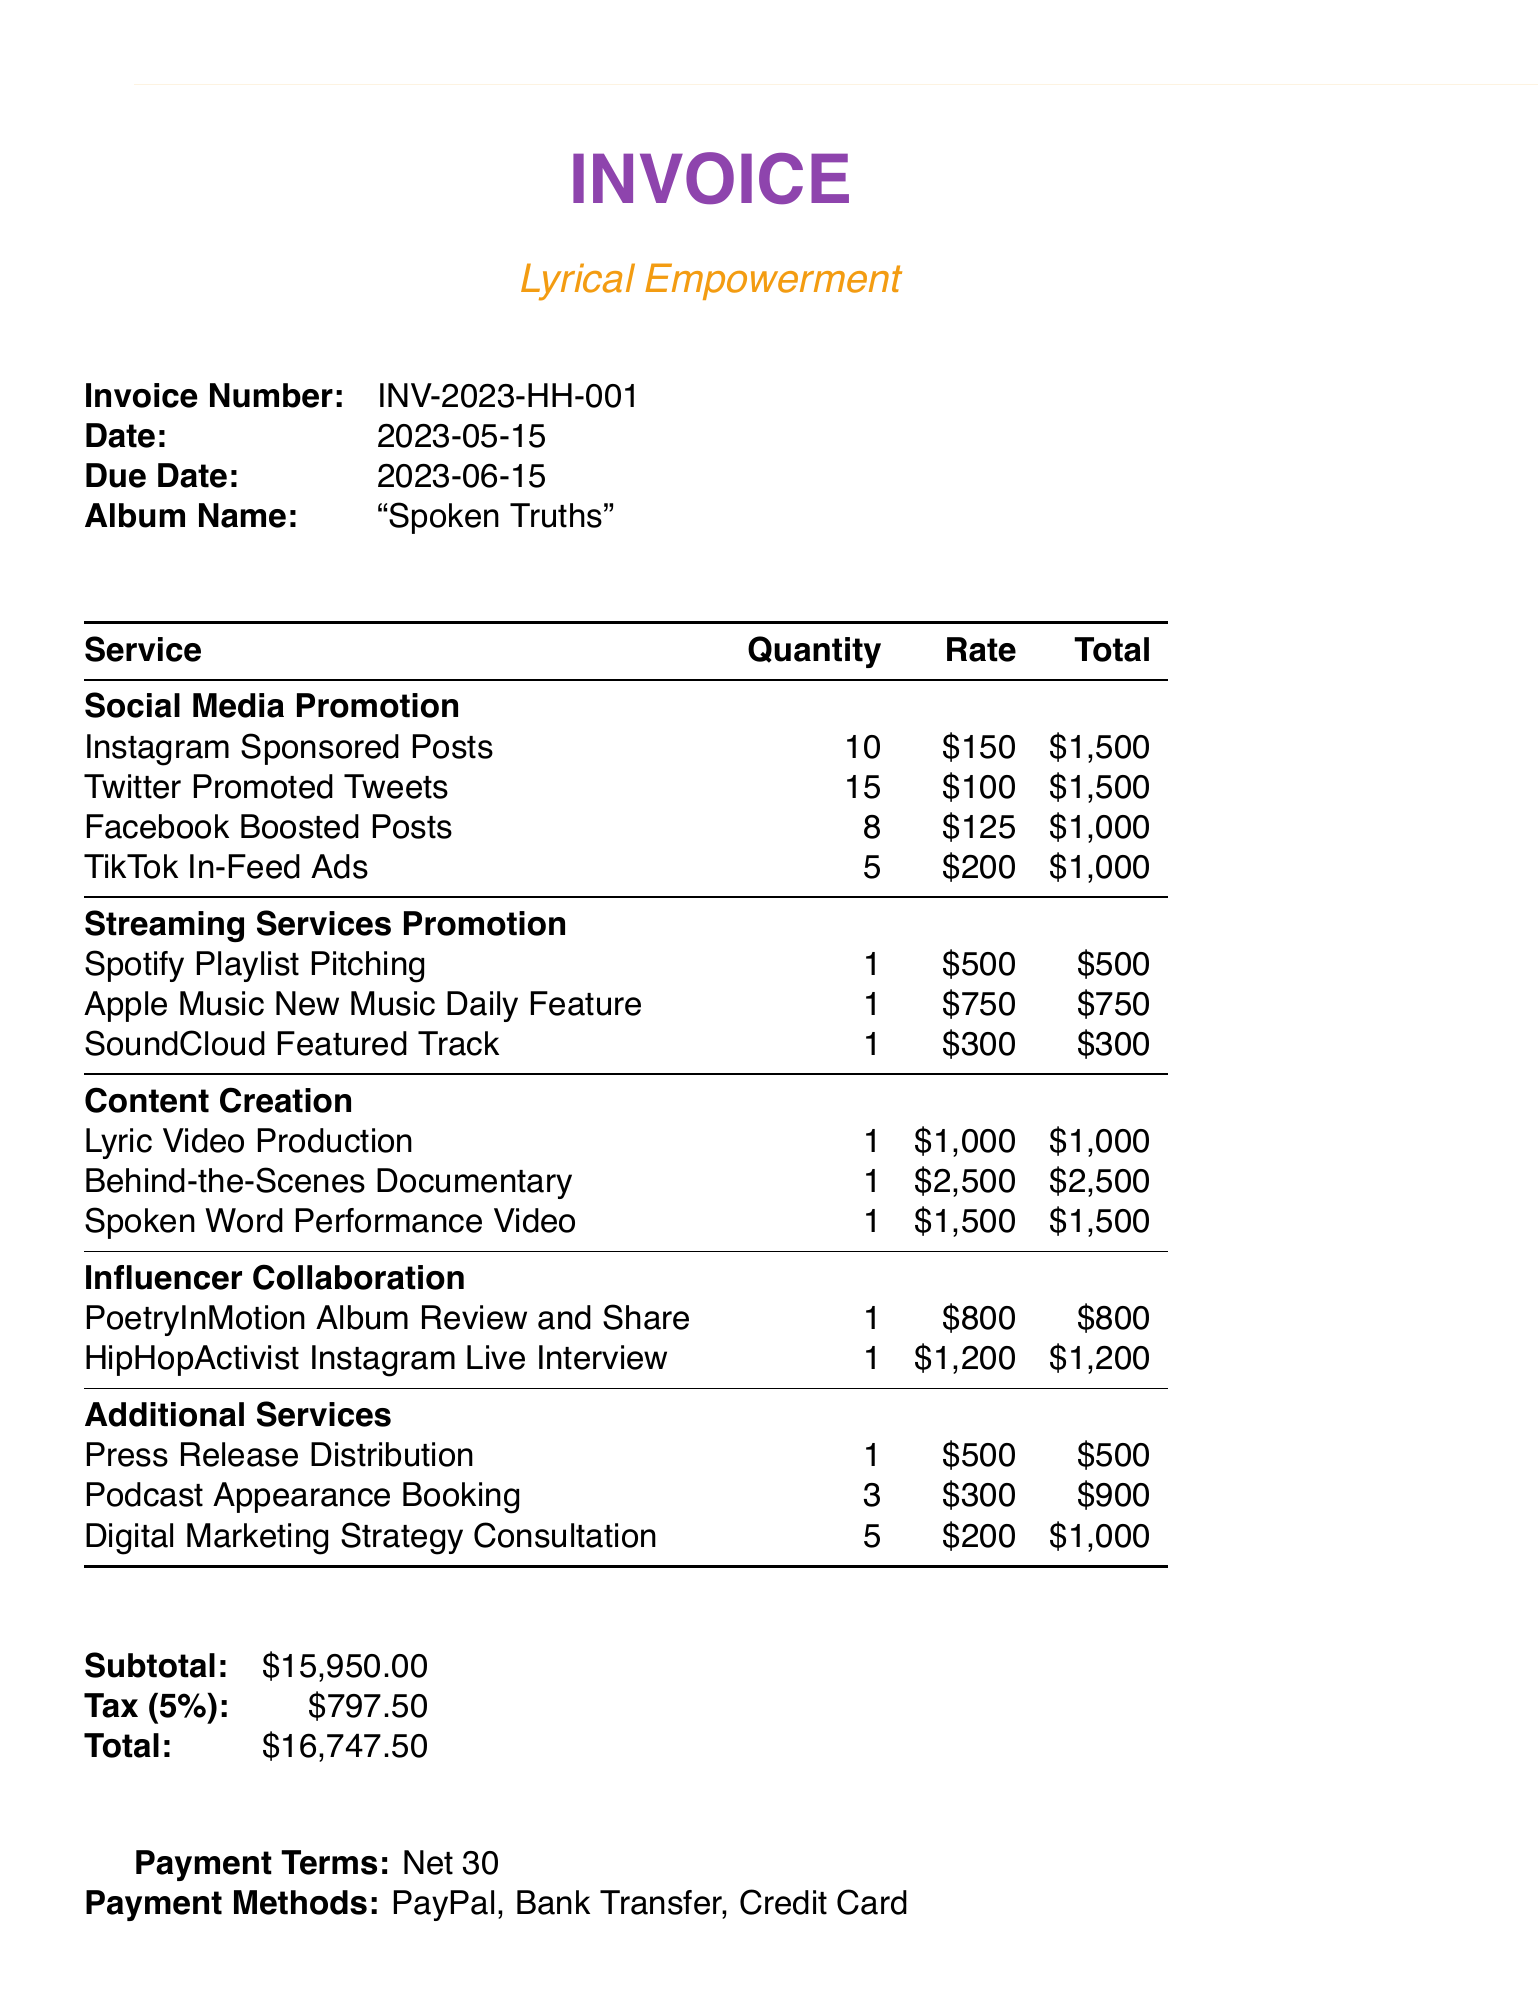What is the invoice number? The invoice number is listed at the top of the document, identifying this specific transaction.
Answer: INV-2023-HH-001 What is the due date? The due date indicates when the payment for this invoice is expected to be completed.
Answer: 2023-06-15 How many Instagram Sponsored Posts are included? The quantity for Instagram Sponsored Posts is specified in the social media promotion section of the document.
Answer: 10 What is the total amount due? The total amount due is calculated from the subtotal and tax presented in the invoice.
Answer: 16747.50 How much is charged for the Behind-the-Scenes Documentary? The charge for the Behind-the-Scenes Documentary is part of the content creation section.
Answer: 2500 Which payment methods are accepted? The invoice mentions various methods available for making the payment.
Answer: PayPal, Bank Transfer, Credit Card What services fall under Streaming Services Promotion? This question requires evaluating multiple entries listed under a specific section in the invoice.
Answer: Spotify Playlist Pitching, Apple Music New Music Daily Feature, SoundCloud Featured Track What is the subtotal amount before tax? The subtotal is the total of all services before tax is applied, shown in the summary of the invoice.
Answer: 15950 Who is the influencer for the Album Review and Share? The influencer's name is detailed in the influencer collaboration section of the invoice.
Answer: PoetryInMotion 